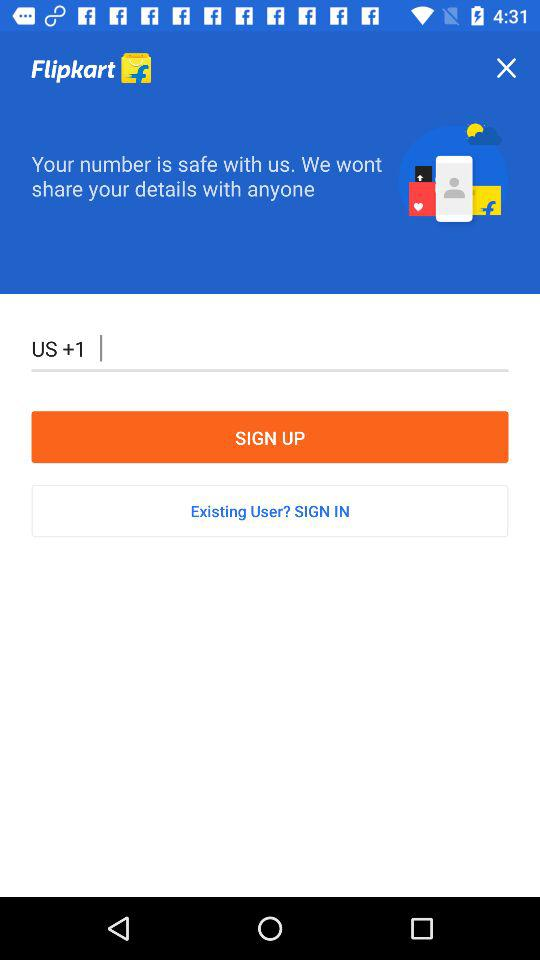What is the user's complete phone number?
When the provided information is insufficient, respond with <no answer>. <no answer> 